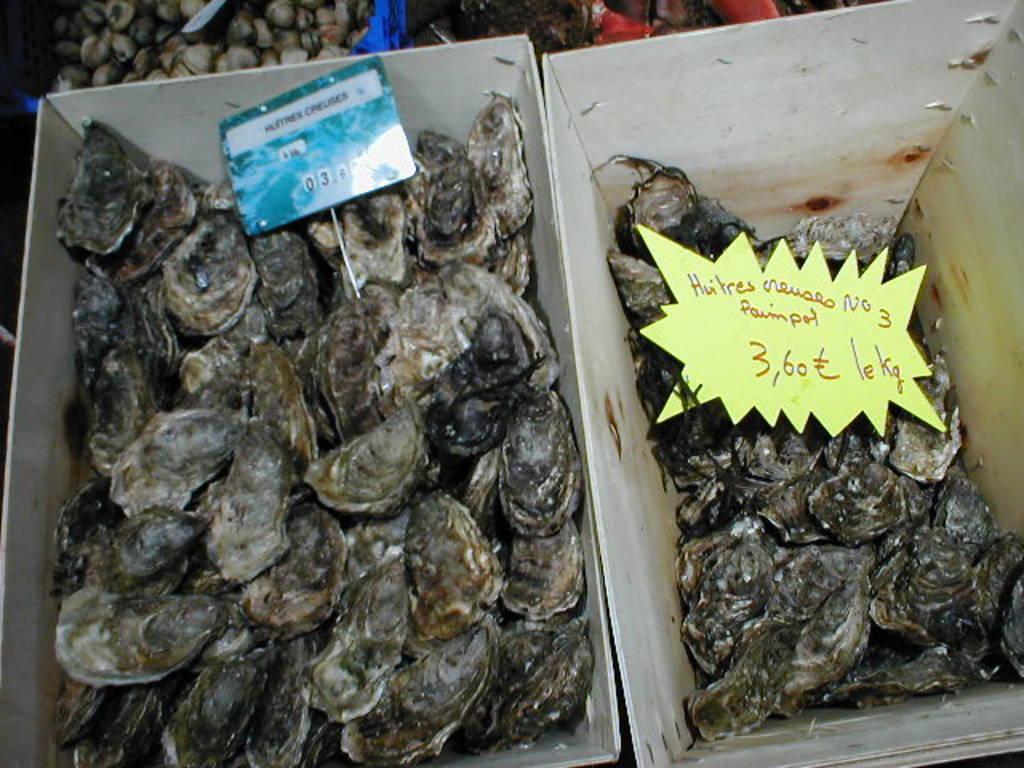In one or two sentences, can you explain what this image depicts? In this image I can see few shells, they are in black, cream and white color in the cardboard box. I can also see two boards in blue and yellow color. 